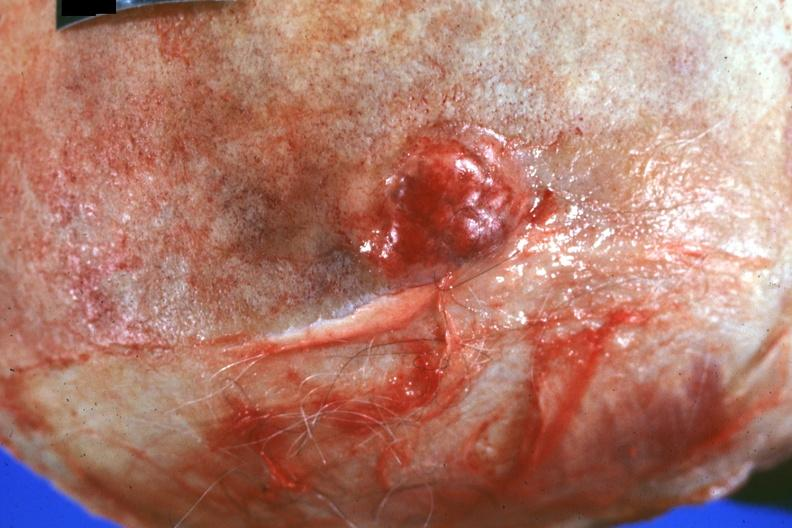does this image show close-up of obvious lesion primary in prostate?
Answer the question using a single word or phrase. Yes 